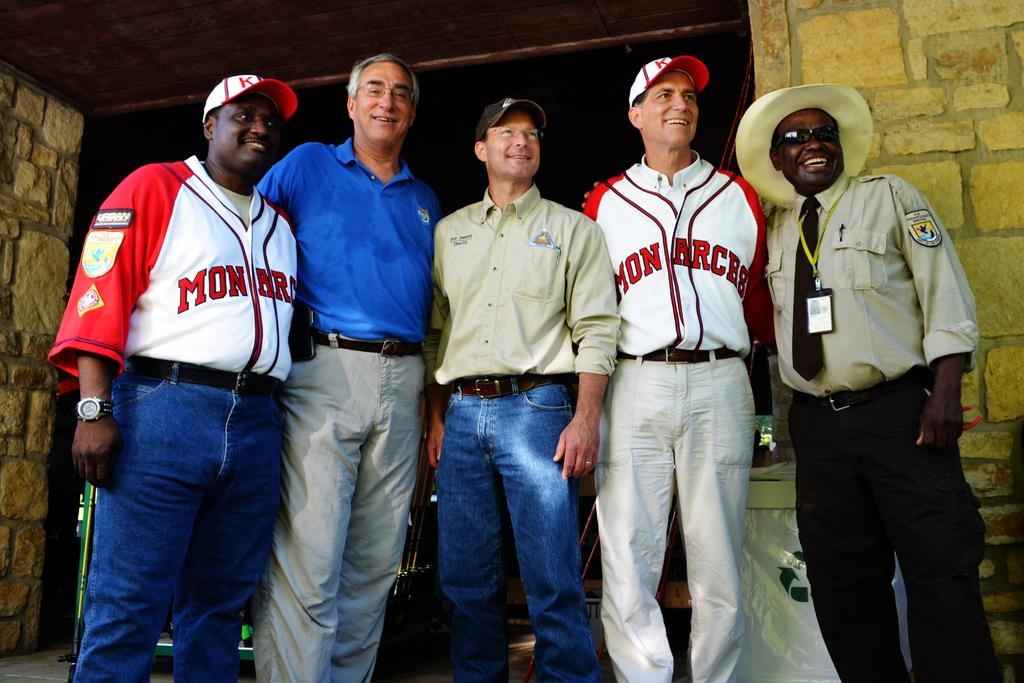<image>
Relay a brief, clear account of the picture shown. a man in a Monarchs jersey posing with others 